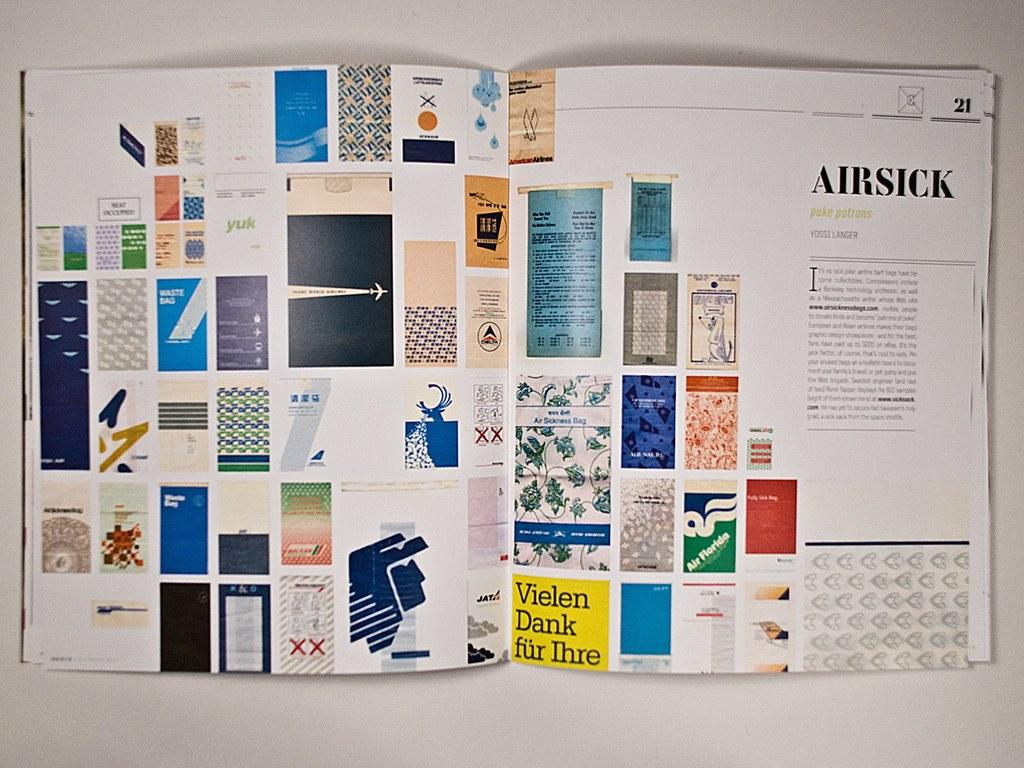<image>
Provide a brief description of the given image. A magazine shows a display of bags and an article on being Airsick 